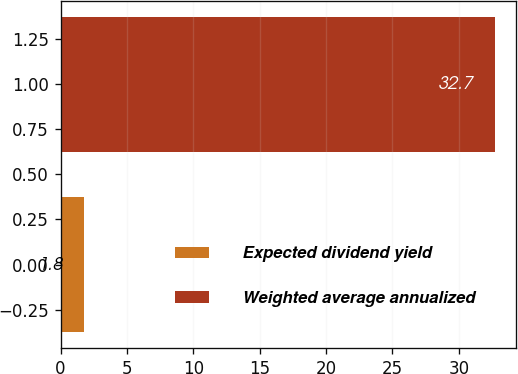<chart> <loc_0><loc_0><loc_500><loc_500><bar_chart><fcel>Expected dividend yield<fcel>Weighted average annualized<nl><fcel>1.8<fcel>32.7<nl></chart> 